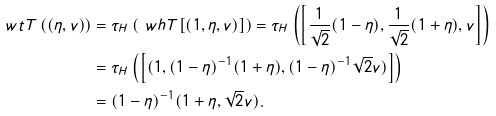<formula> <loc_0><loc_0><loc_500><loc_500>\ w t T \left ( ( \eta , v ) \right ) & = \tau _ { H } \left ( \ w h T [ ( 1 , \eta , v ) ] \right ) = \tau _ { H } \left ( \left [ \frac { 1 } { \sqrt { 2 } } ( 1 - \eta ) , \frac { 1 } { \sqrt { 2 } } ( 1 + \eta ) , v \right ] \right ) \\ & = \tau _ { H } \left ( \left [ ( 1 , ( 1 - \eta ) ^ { - 1 } ( 1 + \eta ) , ( 1 - \eta ) ^ { - 1 } \sqrt { 2 } v ) \right ] \right ) \\ & = ( 1 - \eta ) ^ { - 1 } ( 1 + \eta , \sqrt { 2 } v ) .</formula> 